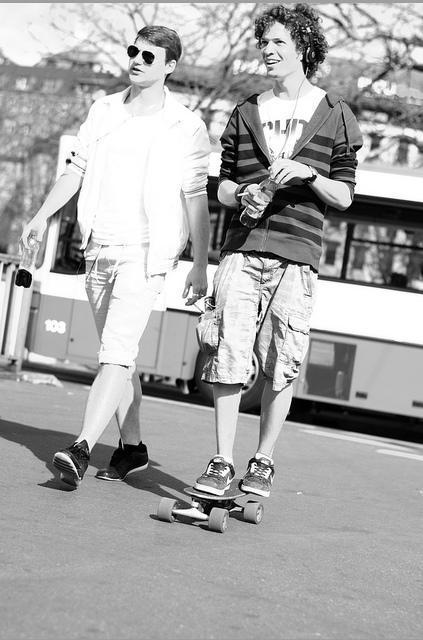What is the person on the left doing?
Indicate the correct response by choosing from the four available options to answer the question.
Options: Studying, eating, walking, writing. Walking. 